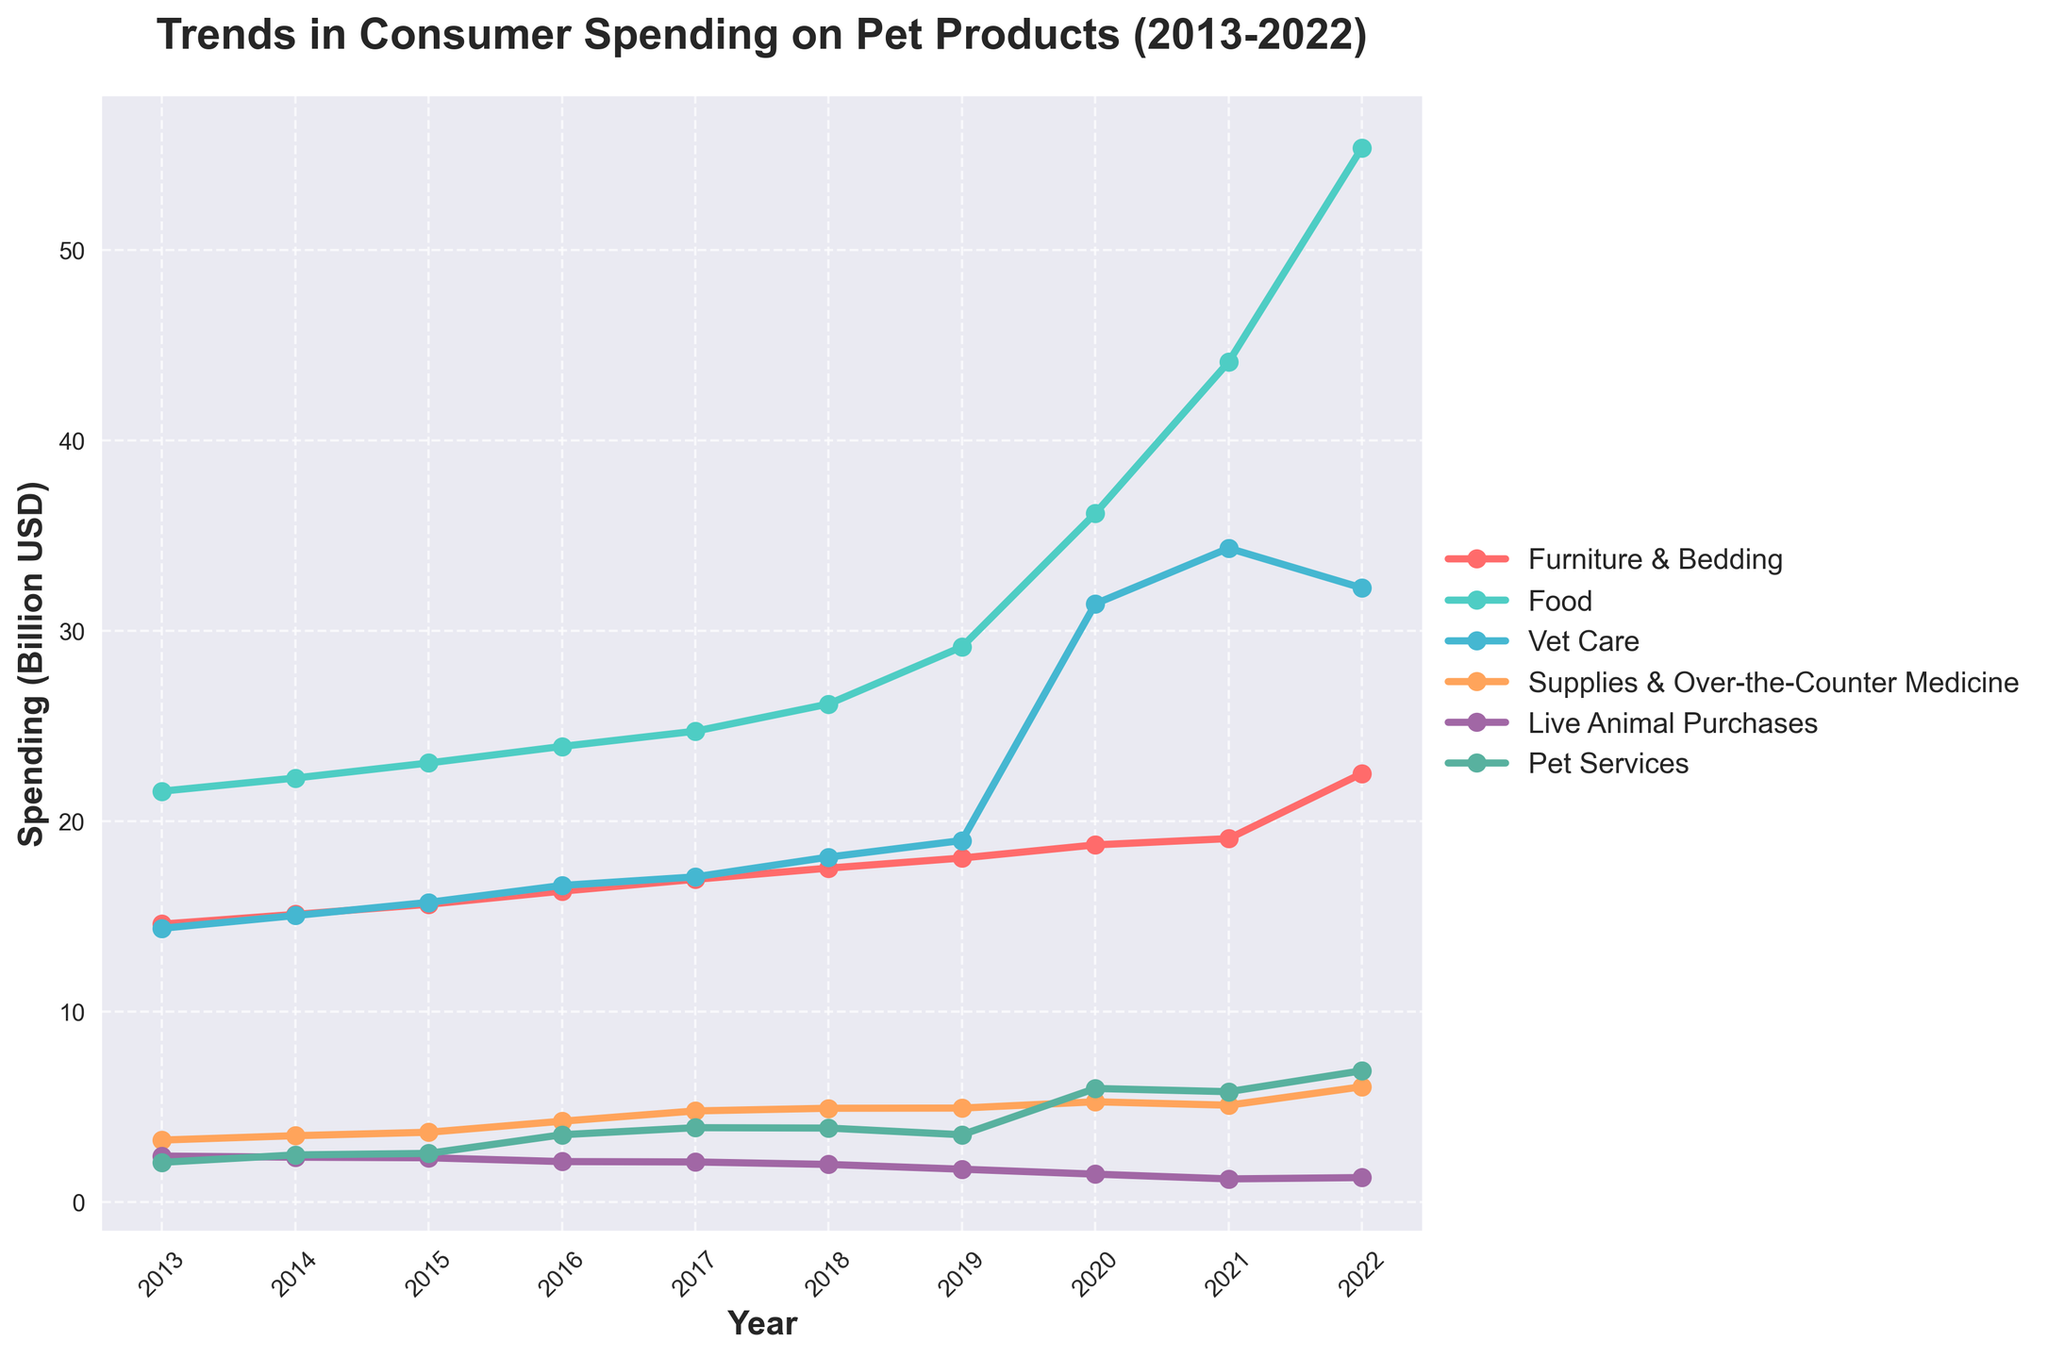What is the title of the plot? The title is located at the top of the plot and provides a description of what the plot is about.
Answer: Trends in Consumer Spending on Pet Products (2013-2022) What is the total consumer spending on pet products in 2020? Refer to the specific point on the plot corresponding to the year 2020 and check the total spending value.
Answer: 99.00 billion USD Which category had the highest spending in 2022 and how much was it? Identify the category line that is highest on the y-axis for the year 2022 and read the value indicated.
Answer: Food, 55.36 billion USD What trends do you observe in spending on 'Vet Care' between 2013 and 2022? Look at the line representing 'Vet Care' and describe its general direction and any significant changes over the years.
Answer: The spending on 'Vet Care' shows a steady increase from 14.37 billion USD in 2013 to 32.24 billion USD in 2022 By how much did the spending on 'Food' increase from 2019 to 2021? Find the values for 'Food' for the years 2019 and 2021, then calculate the difference between these two values.
Answer: 44.11 - 29.15 = 14.96 billion USD Between which years did 'Furniture & Bedding' see the greatest increase in spending? Compare the year-to-year spending values for 'Furniture & Bedding' and identify the years with the largest increase.
Answer: 2021 to 2022 What is the lowest value for 'Live Animal Purchases' observed in the decade, and in which year? Refer to the plot to find the lowest point on the 'Live Animal Purchases' line and identify the corresponding year.
Answer: 1.21 billion USD, 2021 Compare the consumer spending on 'Supplies & Over-the-Counter Medicine' and 'Pet Services' in 2020. Which category had higher spending and by how much? Locate the values for both categories in 2020 and calculate the difference, noting which value is larger.
Answer: Pet Services; 5.96 - 5.26 = 0.70 billion USD What was the average annual spending on 'Furniture & Bedding' over the decade? Sum the annual spending values for 'Furniture & Bedding' from 2013 to 2022 and divide by the number of years (10).
Answer: (14.59 + 15.10 + 15.63 + 16.32 + 16.94 + 17.53 + 18.06 + 18.75 + 19.08 + 22.50) / 10 = 17.15 billion USD How many categories are represented in the plot, and what are the colors used for each category? Count the number of distinct lines in the plot, each representing a different category, and list the color used for each line.
Answer: 6 categories; Furniture & Bedding - red, Food - teal, Vet Care - light blue, Supplies & Over-the-Counter Medicine - orange, Live Animal Purchases - purple, Pet Services - green 